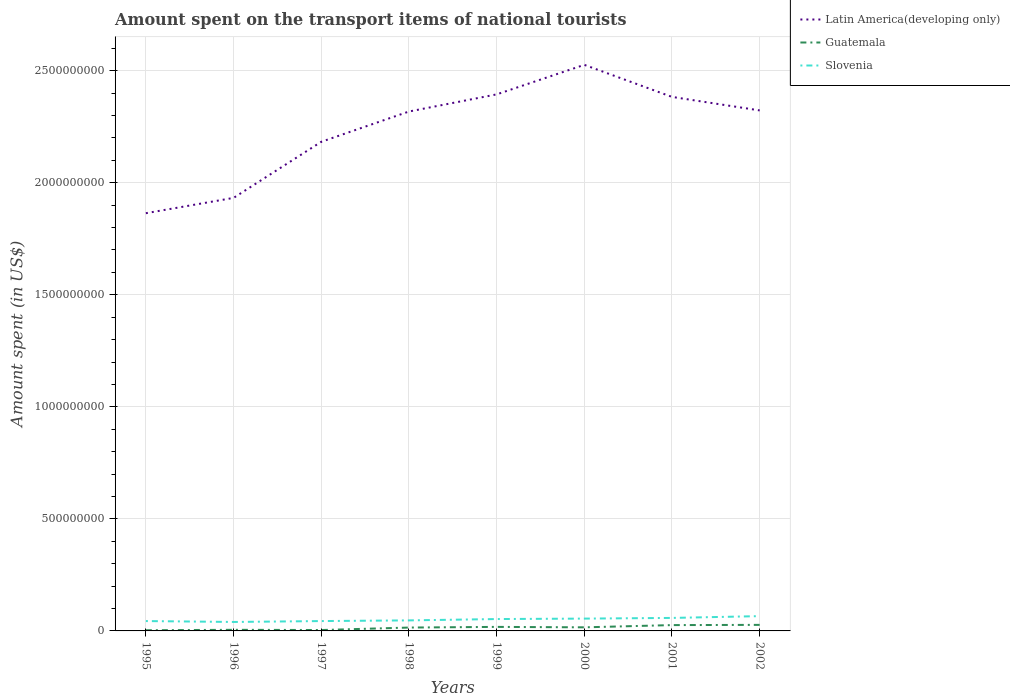In which year was the amount spent on the transport items of national tourists in Slovenia maximum?
Offer a very short reply. 1996. What is the difference between the highest and the second highest amount spent on the transport items of national tourists in Latin America(developing only)?
Provide a succinct answer. 6.62e+08. How many lines are there?
Give a very brief answer. 3. How many years are there in the graph?
Keep it short and to the point. 8. Where does the legend appear in the graph?
Provide a short and direct response. Top right. How are the legend labels stacked?
Your answer should be very brief. Vertical. What is the title of the graph?
Give a very brief answer. Amount spent on the transport items of national tourists. What is the label or title of the X-axis?
Provide a succinct answer. Years. What is the label or title of the Y-axis?
Give a very brief answer. Amount spent (in US$). What is the Amount spent (in US$) of Latin America(developing only) in 1995?
Offer a very short reply. 1.86e+09. What is the Amount spent (in US$) in Slovenia in 1995?
Ensure brevity in your answer.  4.40e+07. What is the Amount spent (in US$) of Latin America(developing only) in 1996?
Give a very brief answer. 1.93e+09. What is the Amount spent (in US$) of Guatemala in 1996?
Give a very brief answer. 5.00e+06. What is the Amount spent (in US$) of Slovenia in 1996?
Provide a short and direct response. 4.00e+07. What is the Amount spent (in US$) of Latin America(developing only) in 1997?
Give a very brief answer. 2.18e+09. What is the Amount spent (in US$) of Guatemala in 1997?
Provide a succinct answer. 4.00e+06. What is the Amount spent (in US$) in Slovenia in 1997?
Your answer should be compact. 4.40e+07. What is the Amount spent (in US$) in Latin America(developing only) in 1998?
Provide a succinct answer. 2.32e+09. What is the Amount spent (in US$) of Guatemala in 1998?
Keep it short and to the point. 1.50e+07. What is the Amount spent (in US$) of Slovenia in 1998?
Ensure brevity in your answer.  4.70e+07. What is the Amount spent (in US$) of Latin America(developing only) in 1999?
Offer a terse response. 2.39e+09. What is the Amount spent (in US$) in Guatemala in 1999?
Give a very brief answer. 1.80e+07. What is the Amount spent (in US$) of Slovenia in 1999?
Your answer should be very brief. 5.30e+07. What is the Amount spent (in US$) of Latin America(developing only) in 2000?
Ensure brevity in your answer.  2.53e+09. What is the Amount spent (in US$) of Guatemala in 2000?
Ensure brevity in your answer.  1.60e+07. What is the Amount spent (in US$) in Slovenia in 2000?
Offer a terse response. 5.50e+07. What is the Amount spent (in US$) in Latin America(developing only) in 2001?
Make the answer very short. 2.38e+09. What is the Amount spent (in US$) in Guatemala in 2001?
Your response must be concise. 2.60e+07. What is the Amount spent (in US$) of Slovenia in 2001?
Make the answer very short. 5.80e+07. What is the Amount spent (in US$) of Latin America(developing only) in 2002?
Keep it short and to the point. 2.32e+09. What is the Amount spent (in US$) of Guatemala in 2002?
Your answer should be compact. 2.70e+07. What is the Amount spent (in US$) of Slovenia in 2002?
Provide a succinct answer. 6.60e+07. Across all years, what is the maximum Amount spent (in US$) of Latin America(developing only)?
Give a very brief answer. 2.53e+09. Across all years, what is the maximum Amount spent (in US$) of Guatemala?
Ensure brevity in your answer.  2.70e+07. Across all years, what is the maximum Amount spent (in US$) of Slovenia?
Provide a short and direct response. 6.60e+07. Across all years, what is the minimum Amount spent (in US$) of Latin America(developing only)?
Your response must be concise. 1.86e+09. Across all years, what is the minimum Amount spent (in US$) in Slovenia?
Make the answer very short. 4.00e+07. What is the total Amount spent (in US$) in Latin America(developing only) in the graph?
Make the answer very short. 1.79e+1. What is the total Amount spent (in US$) in Guatemala in the graph?
Keep it short and to the point. 1.14e+08. What is the total Amount spent (in US$) of Slovenia in the graph?
Provide a short and direct response. 4.07e+08. What is the difference between the Amount spent (in US$) in Latin America(developing only) in 1995 and that in 1996?
Your answer should be very brief. -6.84e+07. What is the difference between the Amount spent (in US$) in Guatemala in 1995 and that in 1996?
Make the answer very short. -2.00e+06. What is the difference between the Amount spent (in US$) of Slovenia in 1995 and that in 1996?
Offer a terse response. 4.00e+06. What is the difference between the Amount spent (in US$) of Latin America(developing only) in 1995 and that in 1997?
Give a very brief answer. -3.19e+08. What is the difference between the Amount spent (in US$) of Guatemala in 1995 and that in 1997?
Your response must be concise. -1.00e+06. What is the difference between the Amount spent (in US$) in Latin America(developing only) in 1995 and that in 1998?
Your answer should be compact. -4.54e+08. What is the difference between the Amount spent (in US$) of Guatemala in 1995 and that in 1998?
Your response must be concise. -1.20e+07. What is the difference between the Amount spent (in US$) of Slovenia in 1995 and that in 1998?
Ensure brevity in your answer.  -3.00e+06. What is the difference between the Amount spent (in US$) of Latin America(developing only) in 1995 and that in 1999?
Provide a succinct answer. -5.30e+08. What is the difference between the Amount spent (in US$) of Guatemala in 1995 and that in 1999?
Make the answer very short. -1.50e+07. What is the difference between the Amount spent (in US$) of Slovenia in 1995 and that in 1999?
Your answer should be compact. -9.00e+06. What is the difference between the Amount spent (in US$) of Latin America(developing only) in 1995 and that in 2000?
Give a very brief answer. -6.62e+08. What is the difference between the Amount spent (in US$) of Guatemala in 1995 and that in 2000?
Ensure brevity in your answer.  -1.30e+07. What is the difference between the Amount spent (in US$) in Slovenia in 1995 and that in 2000?
Your response must be concise. -1.10e+07. What is the difference between the Amount spent (in US$) in Latin America(developing only) in 1995 and that in 2001?
Provide a short and direct response. -5.19e+08. What is the difference between the Amount spent (in US$) in Guatemala in 1995 and that in 2001?
Your answer should be very brief. -2.30e+07. What is the difference between the Amount spent (in US$) of Slovenia in 1995 and that in 2001?
Give a very brief answer. -1.40e+07. What is the difference between the Amount spent (in US$) in Latin America(developing only) in 1995 and that in 2002?
Keep it short and to the point. -4.59e+08. What is the difference between the Amount spent (in US$) in Guatemala in 1995 and that in 2002?
Your answer should be very brief. -2.40e+07. What is the difference between the Amount spent (in US$) in Slovenia in 1995 and that in 2002?
Make the answer very short. -2.20e+07. What is the difference between the Amount spent (in US$) in Latin America(developing only) in 1996 and that in 1997?
Your response must be concise. -2.50e+08. What is the difference between the Amount spent (in US$) in Guatemala in 1996 and that in 1997?
Provide a succinct answer. 1.00e+06. What is the difference between the Amount spent (in US$) in Latin America(developing only) in 1996 and that in 1998?
Your answer should be very brief. -3.85e+08. What is the difference between the Amount spent (in US$) in Guatemala in 1996 and that in 1998?
Ensure brevity in your answer.  -1.00e+07. What is the difference between the Amount spent (in US$) in Slovenia in 1996 and that in 1998?
Make the answer very short. -7.00e+06. What is the difference between the Amount spent (in US$) of Latin America(developing only) in 1996 and that in 1999?
Your answer should be very brief. -4.62e+08. What is the difference between the Amount spent (in US$) of Guatemala in 1996 and that in 1999?
Provide a succinct answer. -1.30e+07. What is the difference between the Amount spent (in US$) of Slovenia in 1996 and that in 1999?
Offer a terse response. -1.30e+07. What is the difference between the Amount spent (in US$) of Latin America(developing only) in 1996 and that in 2000?
Make the answer very short. -5.94e+08. What is the difference between the Amount spent (in US$) of Guatemala in 1996 and that in 2000?
Give a very brief answer. -1.10e+07. What is the difference between the Amount spent (in US$) of Slovenia in 1996 and that in 2000?
Your answer should be compact. -1.50e+07. What is the difference between the Amount spent (in US$) of Latin America(developing only) in 1996 and that in 2001?
Provide a short and direct response. -4.51e+08. What is the difference between the Amount spent (in US$) of Guatemala in 1996 and that in 2001?
Ensure brevity in your answer.  -2.10e+07. What is the difference between the Amount spent (in US$) in Slovenia in 1996 and that in 2001?
Your response must be concise. -1.80e+07. What is the difference between the Amount spent (in US$) of Latin America(developing only) in 1996 and that in 2002?
Make the answer very short. -3.90e+08. What is the difference between the Amount spent (in US$) in Guatemala in 1996 and that in 2002?
Ensure brevity in your answer.  -2.20e+07. What is the difference between the Amount spent (in US$) in Slovenia in 1996 and that in 2002?
Give a very brief answer. -2.60e+07. What is the difference between the Amount spent (in US$) of Latin America(developing only) in 1997 and that in 1998?
Ensure brevity in your answer.  -1.35e+08. What is the difference between the Amount spent (in US$) in Guatemala in 1997 and that in 1998?
Provide a succinct answer. -1.10e+07. What is the difference between the Amount spent (in US$) in Slovenia in 1997 and that in 1998?
Your answer should be compact. -3.00e+06. What is the difference between the Amount spent (in US$) in Latin America(developing only) in 1997 and that in 1999?
Your response must be concise. -2.12e+08. What is the difference between the Amount spent (in US$) of Guatemala in 1997 and that in 1999?
Your response must be concise. -1.40e+07. What is the difference between the Amount spent (in US$) of Slovenia in 1997 and that in 1999?
Provide a succinct answer. -9.00e+06. What is the difference between the Amount spent (in US$) of Latin America(developing only) in 1997 and that in 2000?
Your answer should be compact. -3.43e+08. What is the difference between the Amount spent (in US$) of Guatemala in 1997 and that in 2000?
Provide a short and direct response. -1.20e+07. What is the difference between the Amount spent (in US$) in Slovenia in 1997 and that in 2000?
Keep it short and to the point. -1.10e+07. What is the difference between the Amount spent (in US$) of Latin America(developing only) in 1997 and that in 2001?
Ensure brevity in your answer.  -2.00e+08. What is the difference between the Amount spent (in US$) in Guatemala in 1997 and that in 2001?
Make the answer very short. -2.20e+07. What is the difference between the Amount spent (in US$) in Slovenia in 1997 and that in 2001?
Your answer should be compact. -1.40e+07. What is the difference between the Amount spent (in US$) of Latin America(developing only) in 1997 and that in 2002?
Your response must be concise. -1.40e+08. What is the difference between the Amount spent (in US$) of Guatemala in 1997 and that in 2002?
Ensure brevity in your answer.  -2.30e+07. What is the difference between the Amount spent (in US$) of Slovenia in 1997 and that in 2002?
Offer a terse response. -2.20e+07. What is the difference between the Amount spent (in US$) in Latin America(developing only) in 1998 and that in 1999?
Give a very brief answer. -7.65e+07. What is the difference between the Amount spent (in US$) of Slovenia in 1998 and that in 1999?
Keep it short and to the point. -6.00e+06. What is the difference between the Amount spent (in US$) in Latin America(developing only) in 1998 and that in 2000?
Ensure brevity in your answer.  -2.08e+08. What is the difference between the Amount spent (in US$) in Guatemala in 1998 and that in 2000?
Your answer should be compact. -1.00e+06. What is the difference between the Amount spent (in US$) in Slovenia in 1998 and that in 2000?
Your answer should be compact. -8.00e+06. What is the difference between the Amount spent (in US$) in Latin America(developing only) in 1998 and that in 2001?
Your response must be concise. -6.52e+07. What is the difference between the Amount spent (in US$) in Guatemala in 1998 and that in 2001?
Give a very brief answer. -1.10e+07. What is the difference between the Amount spent (in US$) of Slovenia in 1998 and that in 2001?
Your answer should be compact. -1.10e+07. What is the difference between the Amount spent (in US$) in Latin America(developing only) in 1998 and that in 2002?
Offer a very short reply. -4.95e+06. What is the difference between the Amount spent (in US$) in Guatemala in 1998 and that in 2002?
Make the answer very short. -1.20e+07. What is the difference between the Amount spent (in US$) in Slovenia in 1998 and that in 2002?
Your answer should be very brief. -1.90e+07. What is the difference between the Amount spent (in US$) of Latin America(developing only) in 1999 and that in 2000?
Provide a short and direct response. -1.32e+08. What is the difference between the Amount spent (in US$) in Slovenia in 1999 and that in 2000?
Give a very brief answer. -2.00e+06. What is the difference between the Amount spent (in US$) of Latin America(developing only) in 1999 and that in 2001?
Provide a short and direct response. 1.12e+07. What is the difference between the Amount spent (in US$) of Guatemala in 1999 and that in 2001?
Give a very brief answer. -8.00e+06. What is the difference between the Amount spent (in US$) of Slovenia in 1999 and that in 2001?
Give a very brief answer. -5.00e+06. What is the difference between the Amount spent (in US$) in Latin America(developing only) in 1999 and that in 2002?
Ensure brevity in your answer.  7.15e+07. What is the difference between the Amount spent (in US$) in Guatemala in 1999 and that in 2002?
Give a very brief answer. -9.00e+06. What is the difference between the Amount spent (in US$) in Slovenia in 1999 and that in 2002?
Provide a short and direct response. -1.30e+07. What is the difference between the Amount spent (in US$) in Latin America(developing only) in 2000 and that in 2001?
Provide a short and direct response. 1.43e+08. What is the difference between the Amount spent (in US$) in Guatemala in 2000 and that in 2001?
Provide a succinct answer. -1.00e+07. What is the difference between the Amount spent (in US$) of Slovenia in 2000 and that in 2001?
Offer a terse response. -3.00e+06. What is the difference between the Amount spent (in US$) of Latin America(developing only) in 2000 and that in 2002?
Provide a short and direct response. 2.03e+08. What is the difference between the Amount spent (in US$) in Guatemala in 2000 and that in 2002?
Ensure brevity in your answer.  -1.10e+07. What is the difference between the Amount spent (in US$) in Slovenia in 2000 and that in 2002?
Ensure brevity in your answer.  -1.10e+07. What is the difference between the Amount spent (in US$) of Latin America(developing only) in 2001 and that in 2002?
Your response must be concise. 6.03e+07. What is the difference between the Amount spent (in US$) in Guatemala in 2001 and that in 2002?
Your response must be concise. -1.00e+06. What is the difference between the Amount spent (in US$) in Slovenia in 2001 and that in 2002?
Your answer should be compact. -8.00e+06. What is the difference between the Amount spent (in US$) of Latin America(developing only) in 1995 and the Amount spent (in US$) of Guatemala in 1996?
Make the answer very short. 1.86e+09. What is the difference between the Amount spent (in US$) of Latin America(developing only) in 1995 and the Amount spent (in US$) of Slovenia in 1996?
Give a very brief answer. 1.82e+09. What is the difference between the Amount spent (in US$) of Guatemala in 1995 and the Amount spent (in US$) of Slovenia in 1996?
Provide a succinct answer. -3.70e+07. What is the difference between the Amount spent (in US$) in Latin America(developing only) in 1995 and the Amount spent (in US$) in Guatemala in 1997?
Offer a very short reply. 1.86e+09. What is the difference between the Amount spent (in US$) of Latin America(developing only) in 1995 and the Amount spent (in US$) of Slovenia in 1997?
Offer a very short reply. 1.82e+09. What is the difference between the Amount spent (in US$) in Guatemala in 1995 and the Amount spent (in US$) in Slovenia in 1997?
Your answer should be very brief. -4.10e+07. What is the difference between the Amount spent (in US$) in Latin America(developing only) in 1995 and the Amount spent (in US$) in Guatemala in 1998?
Give a very brief answer. 1.85e+09. What is the difference between the Amount spent (in US$) in Latin America(developing only) in 1995 and the Amount spent (in US$) in Slovenia in 1998?
Provide a succinct answer. 1.82e+09. What is the difference between the Amount spent (in US$) of Guatemala in 1995 and the Amount spent (in US$) of Slovenia in 1998?
Provide a short and direct response. -4.40e+07. What is the difference between the Amount spent (in US$) of Latin America(developing only) in 1995 and the Amount spent (in US$) of Guatemala in 1999?
Provide a succinct answer. 1.85e+09. What is the difference between the Amount spent (in US$) in Latin America(developing only) in 1995 and the Amount spent (in US$) in Slovenia in 1999?
Keep it short and to the point. 1.81e+09. What is the difference between the Amount spent (in US$) of Guatemala in 1995 and the Amount spent (in US$) of Slovenia in 1999?
Give a very brief answer. -5.00e+07. What is the difference between the Amount spent (in US$) of Latin America(developing only) in 1995 and the Amount spent (in US$) of Guatemala in 2000?
Give a very brief answer. 1.85e+09. What is the difference between the Amount spent (in US$) in Latin America(developing only) in 1995 and the Amount spent (in US$) in Slovenia in 2000?
Your answer should be compact. 1.81e+09. What is the difference between the Amount spent (in US$) of Guatemala in 1995 and the Amount spent (in US$) of Slovenia in 2000?
Give a very brief answer. -5.20e+07. What is the difference between the Amount spent (in US$) in Latin America(developing only) in 1995 and the Amount spent (in US$) in Guatemala in 2001?
Make the answer very short. 1.84e+09. What is the difference between the Amount spent (in US$) in Latin America(developing only) in 1995 and the Amount spent (in US$) in Slovenia in 2001?
Give a very brief answer. 1.81e+09. What is the difference between the Amount spent (in US$) in Guatemala in 1995 and the Amount spent (in US$) in Slovenia in 2001?
Your answer should be very brief. -5.50e+07. What is the difference between the Amount spent (in US$) in Latin America(developing only) in 1995 and the Amount spent (in US$) in Guatemala in 2002?
Provide a short and direct response. 1.84e+09. What is the difference between the Amount spent (in US$) of Latin America(developing only) in 1995 and the Amount spent (in US$) of Slovenia in 2002?
Your answer should be very brief. 1.80e+09. What is the difference between the Amount spent (in US$) in Guatemala in 1995 and the Amount spent (in US$) in Slovenia in 2002?
Offer a terse response. -6.30e+07. What is the difference between the Amount spent (in US$) in Latin America(developing only) in 1996 and the Amount spent (in US$) in Guatemala in 1997?
Give a very brief answer. 1.93e+09. What is the difference between the Amount spent (in US$) in Latin America(developing only) in 1996 and the Amount spent (in US$) in Slovenia in 1997?
Ensure brevity in your answer.  1.89e+09. What is the difference between the Amount spent (in US$) of Guatemala in 1996 and the Amount spent (in US$) of Slovenia in 1997?
Make the answer very short. -3.90e+07. What is the difference between the Amount spent (in US$) in Latin America(developing only) in 1996 and the Amount spent (in US$) in Guatemala in 1998?
Your answer should be compact. 1.92e+09. What is the difference between the Amount spent (in US$) in Latin America(developing only) in 1996 and the Amount spent (in US$) in Slovenia in 1998?
Provide a short and direct response. 1.89e+09. What is the difference between the Amount spent (in US$) of Guatemala in 1996 and the Amount spent (in US$) of Slovenia in 1998?
Offer a terse response. -4.20e+07. What is the difference between the Amount spent (in US$) in Latin America(developing only) in 1996 and the Amount spent (in US$) in Guatemala in 1999?
Your answer should be compact. 1.91e+09. What is the difference between the Amount spent (in US$) in Latin America(developing only) in 1996 and the Amount spent (in US$) in Slovenia in 1999?
Your answer should be very brief. 1.88e+09. What is the difference between the Amount spent (in US$) of Guatemala in 1996 and the Amount spent (in US$) of Slovenia in 1999?
Your answer should be very brief. -4.80e+07. What is the difference between the Amount spent (in US$) in Latin America(developing only) in 1996 and the Amount spent (in US$) in Guatemala in 2000?
Offer a very short reply. 1.92e+09. What is the difference between the Amount spent (in US$) in Latin America(developing only) in 1996 and the Amount spent (in US$) in Slovenia in 2000?
Offer a terse response. 1.88e+09. What is the difference between the Amount spent (in US$) of Guatemala in 1996 and the Amount spent (in US$) of Slovenia in 2000?
Ensure brevity in your answer.  -5.00e+07. What is the difference between the Amount spent (in US$) in Latin America(developing only) in 1996 and the Amount spent (in US$) in Guatemala in 2001?
Your answer should be very brief. 1.91e+09. What is the difference between the Amount spent (in US$) in Latin America(developing only) in 1996 and the Amount spent (in US$) in Slovenia in 2001?
Keep it short and to the point. 1.87e+09. What is the difference between the Amount spent (in US$) of Guatemala in 1996 and the Amount spent (in US$) of Slovenia in 2001?
Offer a very short reply. -5.30e+07. What is the difference between the Amount spent (in US$) in Latin America(developing only) in 1996 and the Amount spent (in US$) in Guatemala in 2002?
Make the answer very short. 1.91e+09. What is the difference between the Amount spent (in US$) of Latin America(developing only) in 1996 and the Amount spent (in US$) of Slovenia in 2002?
Offer a very short reply. 1.87e+09. What is the difference between the Amount spent (in US$) of Guatemala in 1996 and the Amount spent (in US$) of Slovenia in 2002?
Your answer should be compact. -6.10e+07. What is the difference between the Amount spent (in US$) in Latin America(developing only) in 1997 and the Amount spent (in US$) in Guatemala in 1998?
Provide a short and direct response. 2.17e+09. What is the difference between the Amount spent (in US$) of Latin America(developing only) in 1997 and the Amount spent (in US$) of Slovenia in 1998?
Your response must be concise. 2.14e+09. What is the difference between the Amount spent (in US$) in Guatemala in 1997 and the Amount spent (in US$) in Slovenia in 1998?
Your response must be concise. -4.30e+07. What is the difference between the Amount spent (in US$) of Latin America(developing only) in 1997 and the Amount spent (in US$) of Guatemala in 1999?
Your response must be concise. 2.16e+09. What is the difference between the Amount spent (in US$) in Latin America(developing only) in 1997 and the Amount spent (in US$) in Slovenia in 1999?
Ensure brevity in your answer.  2.13e+09. What is the difference between the Amount spent (in US$) of Guatemala in 1997 and the Amount spent (in US$) of Slovenia in 1999?
Keep it short and to the point. -4.90e+07. What is the difference between the Amount spent (in US$) of Latin America(developing only) in 1997 and the Amount spent (in US$) of Guatemala in 2000?
Ensure brevity in your answer.  2.17e+09. What is the difference between the Amount spent (in US$) of Latin America(developing only) in 1997 and the Amount spent (in US$) of Slovenia in 2000?
Your answer should be very brief. 2.13e+09. What is the difference between the Amount spent (in US$) in Guatemala in 1997 and the Amount spent (in US$) in Slovenia in 2000?
Offer a terse response. -5.10e+07. What is the difference between the Amount spent (in US$) in Latin America(developing only) in 1997 and the Amount spent (in US$) in Guatemala in 2001?
Provide a succinct answer. 2.16e+09. What is the difference between the Amount spent (in US$) in Latin America(developing only) in 1997 and the Amount spent (in US$) in Slovenia in 2001?
Make the answer very short. 2.12e+09. What is the difference between the Amount spent (in US$) in Guatemala in 1997 and the Amount spent (in US$) in Slovenia in 2001?
Your answer should be compact. -5.40e+07. What is the difference between the Amount spent (in US$) of Latin America(developing only) in 1997 and the Amount spent (in US$) of Guatemala in 2002?
Provide a short and direct response. 2.16e+09. What is the difference between the Amount spent (in US$) of Latin America(developing only) in 1997 and the Amount spent (in US$) of Slovenia in 2002?
Provide a succinct answer. 2.12e+09. What is the difference between the Amount spent (in US$) in Guatemala in 1997 and the Amount spent (in US$) in Slovenia in 2002?
Keep it short and to the point. -6.20e+07. What is the difference between the Amount spent (in US$) in Latin America(developing only) in 1998 and the Amount spent (in US$) in Guatemala in 1999?
Keep it short and to the point. 2.30e+09. What is the difference between the Amount spent (in US$) of Latin America(developing only) in 1998 and the Amount spent (in US$) of Slovenia in 1999?
Keep it short and to the point. 2.26e+09. What is the difference between the Amount spent (in US$) in Guatemala in 1998 and the Amount spent (in US$) in Slovenia in 1999?
Your answer should be very brief. -3.80e+07. What is the difference between the Amount spent (in US$) in Latin America(developing only) in 1998 and the Amount spent (in US$) in Guatemala in 2000?
Give a very brief answer. 2.30e+09. What is the difference between the Amount spent (in US$) in Latin America(developing only) in 1998 and the Amount spent (in US$) in Slovenia in 2000?
Offer a terse response. 2.26e+09. What is the difference between the Amount spent (in US$) in Guatemala in 1998 and the Amount spent (in US$) in Slovenia in 2000?
Provide a short and direct response. -4.00e+07. What is the difference between the Amount spent (in US$) in Latin America(developing only) in 1998 and the Amount spent (in US$) in Guatemala in 2001?
Your response must be concise. 2.29e+09. What is the difference between the Amount spent (in US$) in Latin America(developing only) in 1998 and the Amount spent (in US$) in Slovenia in 2001?
Your answer should be very brief. 2.26e+09. What is the difference between the Amount spent (in US$) of Guatemala in 1998 and the Amount spent (in US$) of Slovenia in 2001?
Provide a short and direct response. -4.30e+07. What is the difference between the Amount spent (in US$) in Latin America(developing only) in 1998 and the Amount spent (in US$) in Guatemala in 2002?
Ensure brevity in your answer.  2.29e+09. What is the difference between the Amount spent (in US$) of Latin America(developing only) in 1998 and the Amount spent (in US$) of Slovenia in 2002?
Offer a very short reply. 2.25e+09. What is the difference between the Amount spent (in US$) in Guatemala in 1998 and the Amount spent (in US$) in Slovenia in 2002?
Keep it short and to the point. -5.10e+07. What is the difference between the Amount spent (in US$) in Latin America(developing only) in 1999 and the Amount spent (in US$) in Guatemala in 2000?
Offer a terse response. 2.38e+09. What is the difference between the Amount spent (in US$) in Latin America(developing only) in 1999 and the Amount spent (in US$) in Slovenia in 2000?
Offer a very short reply. 2.34e+09. What is the difference between the Amount spent (in US$) of Guatemala in 1999 and the Amount spent (in US$) of Slovenia in 2000?
Provide a succinct answer. -3.70e+07. What is the difference between the Amount spent (in US$) of Latin America(developing only) in 1999 and the Amount spent (in US$) of Guatemala in 2001?
Your response must be concise. 2.37e+09. What is the difference between the Amount spent (in US$) in Latin America(developing only) in 1999 and the Amount spent (in US$) in Slovenia in 2001?
Your answer should be compact. 2.34e+09. What is the difference between the Amount spent (in US$) of Guatemala in 1999 and the Amount spent (in US$) of Slovenia in 2001?
Keep it short and to the point. -4.00e+07. What is the difference between the Amount spent (in US$) of Latin America(developing only) in 1999 and the Amount spent (in US$) of Guatemala in 2002?
Your answer should be very brief. 2.37e+09. What is the difference between the Amount spent (in US$) of Latin America(developing only) in 1999 and the Amount spent (in US$) of Slovenia in 2002?
Give a very brief answer. 2.33e+09. What is the difference between the Amount spent (in US$) of Guatemala in 1999 and the Amount spent (in US$) of Slovenia in 2002?
Your answer should be very brief. -4.80e+07. What is the difference between the Amount spent (in US$) of Latin America(developing only) in 2000 and the Amount spent (in US$) of Guatemala in 2001?
Make the answer very short. 2.50e+09. What is the difference between the Amount spent (in US$) in Latin America(developing only) in 2000 and the Amount spent (in US$) in Slovenia in 2001?
Offer a terse response. 2.47e+09. What is the difference between the Amount spent (in US$) in Guatemala in 2000 and the Amount spent (in US$) in Slovenia in 2001?
Ensure brevity in your answer.  -4.20e+07. What is the difference between the Amount spent (in US$) in Latin America(developing only) in 2000 and the Amount spent (in US$) in Guatemala in 2002?
Offer a terse response. 2.50e+09. What is the difference between the Amount spent (in US$) in Latin America(developing only) in 2000 and the Amount spent (in US$) in Slovenia in 2002?
Offer a terse response. 2.46e+09. What is the difference between the Amount spent (in US$) in Guatemala in 2000 and the Amount spent (in US$) in Slovenia in 2002?
Provide a succinct answer. -5.00e+07. What is the difference between the Amount spent (in US$) in Latin America(developing only) in 2001 and the Amount spent (in US$) in Guatemala in 2002?
Provide a succinct answer. 2.36e+09. What is the difference between the Amount spent (in US$) in Latin America(developing only) in 2001 and the Amount spent (in US$) in Slovenia in 2002?
Offer a terse response. 2.32e+09. What is the difference between the Amount spent (in US$) in Guatemala in 2001 and the Amount spent (in US$) in Slovenia in 2002?
Offer a very short reply. -4.00e+07. What is the average Amount spent (in US$) of Latin America(developing only) per year?
Give a very brief answer. 2.24e+09. What is the average Amount spent (in US$) in Guatemala per year?
Offer a terse response. 1.42e+07. What is the average Amount spent (in US$) of Slovenia per year?
Ensure brevity in your answer.  5.09e+07. In the year 1995, what is the difference between the Amount spent (in US$) in Latin America(developing only) and Amount spent (in US$) in Guatemala?
Offer a very short reply. 1.86e+09. In the year 1995, what is the difference between the Amount spent (in US$) of Latin America(developing only) and Amount spent (in US$) of Slovenia?
Offer a terse response. 1.82e+09. In the year 1995, what is the difference between the Amount spent (in US$) of Guatemala and Amount spent (in US$) of Slovenia?
Make the answer very short. -4.10e+07. In the year 1996, what is the difference between the Amount spent (in US$) in Latin America(developing only) and Amount spent (in US$) in Guatemala?
Ensure brevity in your answer.  1.93e+09. In the year 1996, what is the difference between the Amount spent (in US$) of Latin America(developing only) and Amount spent (in US$) of Slovenia?
Your answer should be very brief. 1.89e+09. In the year 1996, what is the difference between the Amount spent (in US$) in Guatemala and Amount spent (in US$) in Slovenia?
Give a very brief answer. -3.50e+07. In the year 1997, what is the difference between the Amount spent (in US$) in Latin America(developing only) and Amount spent (in US$) in Guatemala?
Keep it short and to the point. 2.18e+09. In the year 1997, what is the difference between the Amount spent (in US$) in Latin America(developing only) and Amount spent (in US$) in Slovenia?
Provide a succinct answer. 2.14e+09. In the year 1997, what is the difference between the Amount spent (in US$) in Guatemala and Amount spent (in US$) in Slovenia?
Provide a succinct answer. -4.00e+07. In the year 1998, what is the difference between the Amount spent (in US$) of Latin America(developing only) and Amount spent (in US$) of Guatemala?
Your answer should be very brief. 2.30e+09. In the year 1998, what is the difference between the Amount spent (in US$) in Latin America(developing only) and Amount spent (in US$) in Slovenia?
Give a very brief answer. 2.27e+09. In the year 1998, what is the difference between the Amount spent (in US$) of Guatemala and Amount spent (in US$) of Slovenia?
Keep it short and to the point. -3.20e+07. In the year 1999, what is the difference between the Amount spent (in US$) in Latin America(developing only) and Amount spent (in US$) in Guatemala?
Provide a short and direct response. 2.38e+09. In the year 1999, what is the difference between the Amount spent (in US$) in Latin America(developing only) and Amount spent (in US$) in Slovenia?
Your answer should be compact. 2.34e+09. In the year 1999, what is the difference between the Amount spent (in US$) of Guatemala and Amount spent (in US$) of Slovenia?
Your response must be concise. -3.50e+07. In the year 2000, what is the difference between the Amount spent (in US$) of Latin America(developing only) and Amount spent (in US$) of Guatemala?
Give a very brief answer. 2.51e+09. In the year 2000, what is the difference between the Amount spent (in US$) in Latin America(developing only) and Amount spent (in US$) in Slovenia?
Make the answer very short. 2.47e+09. In the year 2000, what is the difference between the Amount spent (in US$) of Guatemala and Amount spent (in US$) of Slovenia?
Keep it short and to the point. -3.90e+07. In the year 2001, what is the difference between the Amount spent (in US$) in Latin America(developing only) and Amount spent (in US$) in Guatemala?
Offer a terse response. 2.36e+09. In the year 2001, what is the difference between the Amount spent (in US$) in Latin America(developing only) and Amount spent (in US$) in Slovenia?
Make the answer very short. 2.33e+09. In the year 2001, what is the difference between the Amount spent (in US$) in Guatemala and Amount spent (in US$) in Slovenia?
Offer a very short reply. -3.20e+07. In the year 2002, what is the difference between the Amount spent (in US$) in Latin America(developing only) and Amount spent (in US$) in Guatemala?
Provide a short and direct response. 2.30e+09. In the year 2002, what is the difference between the Amount spent (in US$) of Latin America(developing only) and Amount spent (in US$) of Slovenia?
Offer a very short reply. 2.26e+09. In the year 2002, what is the difference between the Amount spent (in US$) in Guatemala and Amount spent (in US$) in Slovenia?
Ensure brevity in your answer.  -3.90e+07. What is the ratio of the Amount spent (in US$) of Latin America(developing only) in 1995 to that in 1996?
Provide a succinct answer. 0.96. What is the ratio of the Amount spent (in US$) of Slovenia in 1995 to that in 1996?
Provide a short and direct response. 1.1. What is the ratio of the Amount spent (in US$) in Latin America(developing only) in 1995 to that in 1997?
Offer a terse response. 0.85. What is the ratio of the Amount spent (in US$) in Guatemala in 1995 to that in 1997?
Ensure brevity in your answer.  0.75. What is the ratio of the Amount spent (in US$) in Latin America(developing only) in 1995 to that in 1998?
Provide a succinct answer. 0.8. What is the ratio of the Amount spent (in US$) in Slovenia in 1995 to that in 1998?
Your answer should be very brief. 0.94. What is the ratio of the Amount spent (in US$) of Latin America(developing only) in 1995 to that in 1999?
Provide a succinct answer. 0.78. What is the ratio of the Amount spent (in US$) of Guatemala in 1995 to that in 1999?
Provide a short and direct response. 0.17. What is the ratio of the Amount spent (in US$) of Slovenia in 1995 to that in 1999?
Offer a very short reply. 0.83. What is the ratio of the Amount spent (in US$) of Latin America(developing only) in 1995 to that in 2000?
Offer a terse response. 0.74. What is the ratio of the Amount spent (in US$) in Guatemala in 1995 to that in 2000?
Provide a succinct answer. 0.19. What is the ratio of the Amount spent (in US$) of Latin America(developing only) in 1995 to that in 2001?
Offer a terse response. 0.78. What is the ratio of the Amount spent (in US$) of Guatemala in 1995 to that in 2001?
Give a very brief answer. 0.12. What is the ratio of the Amount spent (in US$) in Slovenia in 1995 to that in 2001?
Provide a short and direct response. 0.76. What is the ratio of the Amount spent (in US$) in Latin America(developing only) in 1995 to that in 2002?
Your response must be concise. 0.8. What is the ratio of the Amount spent (in US$) in Guatemala in 1995 to that in 2002?
Offer a terse response. 0.11. What is the ratio of the Amount spent (in US$) of Latin America(developing only) in 1996 to that in 1997?
Your answer should be compact. 0.89. What is the ratio of the Amount spent (in US$) in Guatemala in 1996 to that in 1997?
Ensure brevity in your answer.  1.25. What is the ratio of the Amount spent (in US$) in Slovenia in 1996 to that in 1997?
Give a very brief answer. 0.91. What is the ratio of the Amount spent (in US$) of Latin America(developing only) in 1996 to that in 1998?
Offer a very short reply. 0.83. What is the ratio of the Amount spent (in US$) of Guatemala in 1996 to that in 1998?
Offer a terse response. 0.33. What is the ratio of the Amount spent (in US$) in Slovenia in 1996 to that in 1998?
Your response must be concise. 0.85. What is the ratio of the Amount spent (in US$) in Latin America(developing only) in 1996 to that in 1999?
Offer a very short reply. 0.81. What is the ratio of the Amount spent (in US$) in Guatemala in 1996 to that in 1999?
Keep it short and to the point. 0.28. What is the ratio of the Amount spent (in US$) in Slovenia in 1996 to that in 1999?
Keep it short and to the point. 0.75. What is the ratio of the Amount spent (in US$) of Latin America(developing only) in 1996 to that in 2000?
Provide a succinct answer. 0.77. What is the ratio of the Amount spent (in US$) of Guatemala in 1996 to that in 2000?
Your answer should be very brief. 0.31. What is the ratio of the Amount spent (in US$) in Slovenia in 1996 to that in 2000?
Provide a succinct answer. 0.73. What is the ratio of the Amount spent (in US$) of Latin America(developing only) in 1996 to that in 2001?
Provide a short and direct response. 0.81. What is the ratio of the Amount spent (in US$) of Guatemala in 1996 to that in 2001?
Offer a very short reply. 0.19. What is the ratio of the Amount spent (in US$) of Slovenia in 1996 to that in 2001?
Provide a succinct answer. 0.69. What is the ratio of the Amount spent (in US$) of Latin America(developing only) in 1996 to that in 2002?
Offer a very short reply. 0.83. What is the ratio of the Amount spent (in US$) in Guatemala in 1996 to that in 2002?
Ensure brevity in your answer.  0.19. What is the ratio of the Amount spent (in US$) in Slovenia in 1996 to that in 2002?
Offer a terse response. 0.61. What is the ratio of the Amount spent (in US$) in Latin America(developing only) in 1997 to that in 1998?
Your response must be concise. 0.94. What is the ratio of the Amount spent (in US$) in Guatemala in 1997 to that in 1998?
Give a very brief answer. 0.27. What is the ratio of the Amount spent (in US$) in Slovenia in 1997 to that in 1998?
Your answer should be very brief. 0.94. What is the ratio of the Amount spent (in US$) in Latin America(developing only) in 1997 to that in 1999?
Your answer should be compact. 0.91. What is the ratio of the Amount spent (in US$) in Guatemala in 1997 to that in 1999?
Ensure brevity in your answer.  0.22. What is the ratio of the Amount spent (in US$) of Slovenia in 1997 to that in 1999?
Give a very brief answer. 0.83. What is the ratio of the Amount spent (in US$) of Latin America(developing only) in 1997 to that in 2000?
Your answer should be compact. 0.86. What is the ratio of the Amount spent (in US$) of Guatemala in 1997 to that in 2000?
Make the answer very short. 0.25. What is the ratio of the Amount spent (in US$) of Latin America(developing only) in 1997 to that in 2001?
Offer a terse response. 0.92. What is the ratio of the Amount spent (in US$) of Guatemala in 1997 to that in 2001?
Your response must be concise. 0.15. What is the ratio of the Amount spent (in US$) in Slovenia in 1997 to that in 2001?
Give a very brief answer. 0.76. What is the ratio of the Amount spent (in US$) of Latin America(developing only) in 1997 to that in 2002?
Offer a terse response. 0.94. What is the ratio of the Amount spent (in US$) in Guatemala in 1997 to that in 2002?
Offer a terse response. 0.15. What is the ratio of the Amount spent (in US$) of Latin America(developing only) in 1998 to that in 1999?
Give a very brief answer. 0.97. What is the ratio of the Amount spent (in US$) in Guatemala in 1998 to that in 1999?
Keep it short and to the point. 0.83. What is the ratio of the Amount spent (in US$) of Slovenia in 1998 to that in 1999?
Give a very brief answer. 0.89. What is the ratio of the Amount spent (in US$) in Latin America(developing only) in 1998 to that in 2000?
Your answer should be compact. 0.92. What is the ratio of the Amount spent (in US$) in Guatemala in 1998 to that in 2000?
Offer a terse response. 0.94. What is the ratio of the Amount spent (in US$) of Slovenia in 1998 to that in 2000?
Give a very brief answer. 0.85. What is the ratio of the Amount spent (in US$) in Latin America(developing only) in 1998 to that in 2001?
Provide a short and direct response. 0.97. What is the ratio of the Amount spent (in US$) of Guatemala in 1998 to that in 2001?
Provide a short and direct response. 0.58. What is the ratio of the Amount spent (in US$) in Slovenia in 1998 to that in 2001?
Your answer should be very brief. 0.81. What is the ratio of the Amount spent (in US$) of Latin America(developing only) in 1998 to that in 2002?
Ensure brevity in your answer.  1. What is the ratio of the Amount spent (in US$) of Guatemala in 1998 to that in 2002?
Give a very brief answer. 0.56. What is the ratio of the Amount spent (in US$) in Slovenia in 1998 to that in 2002?
Provide a succinct answer. 0.71. What is the ratio of the Amount spent (in US$) in Latin America(developing only) in 1999 to that in 2000?
Give a very brief answer. 0.95. What is the ratio of the Amount spent (in US$) of Slovenia in 1999 to that in 2000?
Ensure brevity in your answer.  0.96. What is the ratio of the Amount spent (in US$) in Guatemala in 1999 to that in 2001?
Ensure brevity in your answer.  0.69. What is the ratio of the Amount spent (in US$) in Slovenia in 1999 to that in 2001?
Offer a terse response. 0.91. What is the ratio of the Amount spent (in US$) in Latin America(developing only) in 1999 to that in 2002?
Provide a short and direct response. 1.03. What is the ratio of the Amount spent (in US$) of Slovenia in 1999 to that in 2002?
Provide a short and direct response. 0.8. What is the ratio of the Amount spent (in US$) of Latin America(developing only) in 2000 to that in 2001?
Your answer should be compact. 1.06. What is the ratio of the Amount spent (in US$) of Guatemala in 2000 to that in 2001?
Provide a short and direct response. 0.62. What is the ratio of the Amount spent (in US$) in Slovenia in 2000 to that in 2001?
Offer a terse response. 0.95. What is the ratio of the Amount spent (in US$) in Latin America(developing only) in 2000 to that in 2002?
Offer a very short reply. 1.09. What is the ratio of the Amount spent (in US$) of Guatemala in 2000 to that in 2002?
Give a very brief answer. 0.59. What is the ratio of the Amount spent (in US$) in Latin America(developing only) in 2001 to that in 2002?
Ensure brevity in your answer.  1.03. What is the ratio of the Amount spent (in US$) in Guatemala in 2001 to that in 2002?
Provide a succinct answer. 0.96. What is the ratio of the Amount spent (in US$) in Slovenia in 2001 to that in 2002?
Your answer should be very brief. 0.88. What is the difference between the highest and the second highest Amount spent (in US$) in Latin America(developing only)?
Provide a succinct answer. 1.32e+08. What is the difference between the highest and the lowest Amount spent (in US$) in Latin America(developing only)?
Offer a terse response. 6.62e+08. What is the difference between the highest and the lowest Amount spent (in US$) of Guatemala?
Keep it short and to the point. 2.40e+07. What is the difference between the highest and the lowest Amount spent (in US$) of Slovenia?
Offer a very short reply. 2.60e+07. 